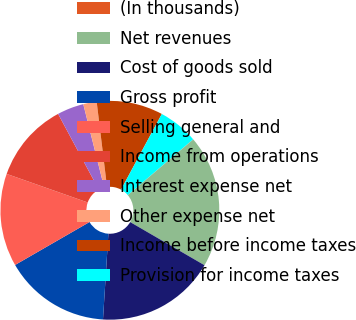<chart> <loc_0><loc_0><loc_500><loc_500><pie_chart><fcel>(In thousands)<fcel>Net revenues<fcel>Cost of goods sold<fcel>Gross profit<fcel>Selling general and<fcel>Income from operations<fcel>Interest expense net<fcel>Other expense net<fcel>Income before income taxes<fcel>Provision for income taxes<nl><fcel>0.03%<fcel>19.58%<fcel>17.63%<fcel>15.67%<fcel>13.72%<fcel>11.76%<fcel>3.94%<fcel>1.98%<fcel>9.8%<fcel>5.89%<nl></chart> 